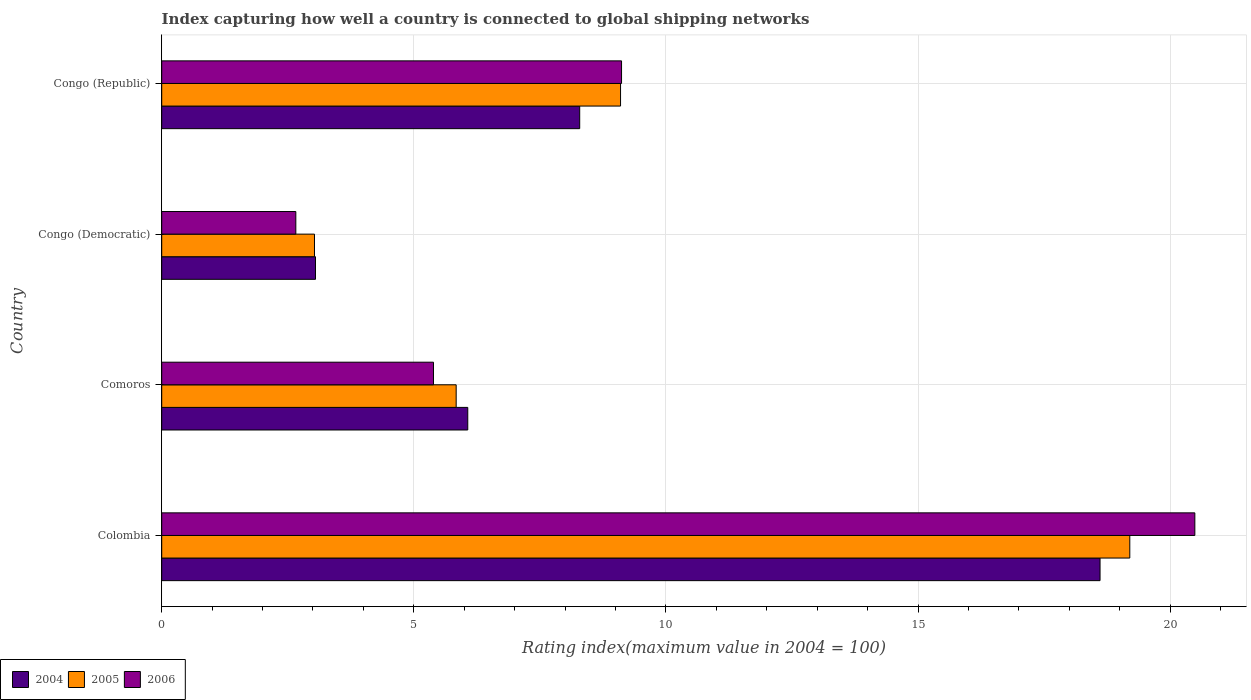How many different coloured bars are there?
Your answer should be very brief. 3. How many groups of bars are there?
Ensure brevity in your answer.  4. Are the number of bars on each tick of the Y-axis equal?
Your answer should be very brief. Yes. How many bars are there on the 2nd tick from the top?
Provide a succinct answer. 3. What is the label of the 3rd group of bars from the top?
Your answer should be compact. Comoros. What is the rating index in 2005 in Congo (Democratic)?
Make the answer very short. 3.03. Across all countries, what is the maximum rating index in 2006?
Your answer should be compact. 20.49. Across all countries, what is the minimum rating index in 2004?
Offer a very short reply. 3.05. In which country was the rating index in 2006 maximum?
Make the answer very short. Colombia. In which country was the rating index in 2006 minimum?
Offer a very short reply. Congo (Democratic). What is the total rating index in 2004 in the graph?
Ensure brevity in your answer.  36.02. What is the difference between the rating index in 2005 in Colombia and that in Comoros?
Ensure brevity in your answer.  13.36. What is the difference between the rating index in 2005 in Congo (Republic) and the rating index in 2004 in Congo (Democratic)?
Provide a succinct answer. 6.05. What is the average rating index in 2006 per country?
Your answer should be very brief. 9.41. What is the difference between the rating index in 2005 and rating index in 2004 in Congo (Democratic)?
Offer a very short reply. -0.02. In how many countries, is the rating index in 2005 greater than 9 ?
Give a very brief answer. 2. What is the ratio of the rating index in 2004 in Colombia to that in Comoros?
Your answer should be very brief. 3.07. Is the rating index in 2004 in Congo (Democratic) less than that in Congo (Republic)?
Your response must be concise. Yes. Is the difference between the rating index in 2005 in Colombia and Congo (Democratic) greater than the difference between the rating index in 2004 in Colombia and Congo (Democratic)?
Offer a very short reply. Yes. What is the difference between the highest and the second highest rating index in 2004?
Your response must be concise. 10.32. What is the difference between the highest and the lowest rating index in 2005?
Keep it short and to the point. 16.17. In how many countries, is the rating index in 2006 greater than the average rating index in 2006 taken over all countries?
Your answer should be very brief. 1. Is the sum of the rating index in 2004 in Congo (Democratic) and Congo (Republic) greater than the maximum rating index in 2006 across all countries?
Provide a short and direct response. No. What does the 1st bar from the bottom in Comoros represents?
Provide a short and direct response. 2004. Is it the case that in every country, the sum of the rating index in 2005 and rating index in 2006 is greater than the rating index in 2004?
Your response must be concise. Yes. How many countries are there in the graph?
Offer a terse response. 4. What is the difference between two consecutive major ticks on the X-axis?
Your response must be concise. 5. Does the graph contain any zero values?
Ensure brevity in your answer.  No. How many legend labels are there?
Ensure brevity in your answer.  3. How are the legend labels stacked?
Give a very brief answer. Horizontal. What is the title of the graph?
Your answer should be compact. Index capturing how well a country is connected to global shipping networks. Does "1985" appear as one of the legend labels in the graph?
Keep it short and to the point. No. What is the label or title of the X-axis?
Provide a short and direct response. Rating index(maximum value in 2004 = 100). What is the label or title of the Y-axis?
Your answer should be compact. Country. What is the Rating index(maximum value in 2004 = 100) in 2004 in Colombia?
Provide a succinct answer. 18.61. What is the Rating index(maximum value in 2004 = 100) in 2006 in Colombia?
Ensure brevity in your answer.  20.49. What is the Rating index(maximum value in 2004 = 100) of 2004 in Comoros?
Your answer should be compact. 6.07. What is the Rating index(maximum value in 2004 = 100) of 2005 in Comoros?
Your answer should be compact. 5.84. What is the Rating index(maximum value in 2004 = 100) in 2006 in Comoros?
Your answer should be compact. 5.39. What is the Rating index(maximum value in 2004 = 100) of 2004 in Congo (Democratic)?
Keep it short and to the point. 3.05. What is the Rating index(maximum value in 2004 = 100) of 2005 in Congo (Democratic)?
Keep it short and to the point. 3.03. What is the Rating index(maximum value in 2004 = 100) of 2006 in Congo (Democratic)?
Your answer should be very brief. 2.66. What is the Rating index(maximum value in 2004 = 100) in 2004 in Congo (Republic)?
Provide a short and direct response. 8.29. What is the Rating index(maximum value in 2004 = 100) in 2006 in Congo (Republic)?
Provide a succinct answer. 9.12. Across all countries, what is the maximum Rating index(maximum value in 2004 = 100) in 2004?
Offer a terse response. 18.61. Across all countries, what is the maximum Rating index(maximum value in 2004 = 100) in 2006?
Offer a very short reply. 20.49. Across all countries, what is the minimum Rating index(maximum value in 2004 = 100) in 2004?
Provide a succinct answer. 3.05. Across all countries, what is the minimum Rating index(maximum value in 2004 = 100) in 2005?
Offer a very short reply. 3.03. Across all countries, what is the minimum Rating index(maximum value in 2004 = 100) in 2006?
Offer a terse response. 2.66. What is the total Rating index(maximum value in 2004 = 100) of 2004 in the graph?
Give a very brief answer. 36.02. What is the total Rating index(maximum value in 2004 = 100) of 2005 in the graph?
Offer a terse response. 37.17. What is the total Rating index(maximum value in 2004 = 100) in 2006 in the graph?
Make the answer very short. 37.66. What is the difference between the Rating index(maximum value in 2004 = 100) of 2004 in Colombia and that in Comoros?
Give a very brief answer. 12.54. What is the difference between the Rating index(maximum value in 2004 = 100) of 2005 in Colombia and that in Comoros?
Keep it short and to the point. 13.36. What is the difference between the Rating index(maximum value in 2004 = 100) of 2006 in Colombia and that in Comoros?
Offer a very short reply. 15.1. What is the difference between the Rating index(maximum value in 2004 = 100) in 2004 in Colombia and that in Congo (Democratic)?
Make the answer very short. 15.56. What is the difference between the Rating index(maximum value in 2004 = 100) in 2005 in Colombia and that in Congo (Democratic)?
Give a very brief answer. 16.17. What is the difference between the Rating index(maximum value in 2004 = 100) in 2006 in Colombia and that in Congo (Democratic)?
Give a very brief answer. 17.83. What is the difference between the Rating index(maximum value in 2004 = 100) of 2004 in Colombia and that in Congo (Republic)?
Offer a terse response. 10.32. What is the difference between the Rating index(maximum value in 2004 = 100) in 2005 in Colombia and that in Congo (Republic)?
Provide a short and direct response. 10.1. What is the difference between the Rating index(maximum value in 2004 = 100) of 2006 in Colombia and that in Congo (Republic)?
Make the answer very short. 11.37. What is the difference between the Rating index(maximum value in 2004 = 100) of 2004 in Comoros and that in Congo (Democratic)?
Offer a terse response. 3.02. What is the difference between the Rating index(maximum value in 2004 = 100) of 2005 in Comoros and that in Congo (Democratic)?
Make the answer very short. 2.81. What is the difference between the Rating index(maximum value in 2004 = 100) in 2006 in Comoros and that in Congo (Democratic)?
Give a very brief answer. 2.73. What is the difference between the Rating index(maximum value in 2004 = 100) of 2004 in Comoros and that in Congo (Republic)?
Provide a succinct answer. -2.22. What is the difference between the Rating index(maximum value in 2004 = 100) in 2005 in Comoros and that in Congo (Republic)?
Your response must be concise. -3.26. What is the difference between the Rating index(maximum value in 2004 = 100) of 2006 in Comoros and that in Congo (Republic)?
Your answer should be very brief. -3.73. What is the difference between the Rating index(maximum value in 2004 = 100) in 2004 in Congo (Democratic) and that in Congo (Republic)?
Offer a terse response. -5.24. What is the difference between the Rating index(maximum value in 2004 = 100) in 2005 in Congo (Democratic) and that in Congo (Republic)?
Ensure brevity in your answer.  -6.07. What is the difference between the Rating index(maximum value in 2004 = 100) in 2006 in Congo (Democratic) and that in Congo (Republic)?
Keep it short and to the point. -6.46. What is the difference between the Rating index(maximum value in 2004 = 100) in 2004 in Colombia and the Rating index(maximum value in 2004 = 100) in 2005 in Comoros?
Keep it short and to the point. 12.77. What is the difference between the Rating index(maximum value in 2004 = 100) of 2004 in Colombia and the Rating index(maximum value in 2004 = 100) of 2006 in Comoros?
Your response must be concise. 13.22. What is the difference between the Rating index(maximum value in 2004 = 100) in 2005 in Colombia and the Rating index(maximum value in 2004 = 100) in 2006 in Comoros?
Provide a short and direct response. 13.81. What is the difference between the Rating index(maximum value in 2004 = 100) of 2004 in Colombia and the Rating index(maximum value in 2004 = 100) of 2005 in Congo (Democratic)?
Offer a very short reply. 15.58. What is the difference between the Rating index(maximum value in 2004 = 100) in 2004 in Colombia and the Rating index(maximum value in 2004 = 100) in 2006 in Congo (Democratic)?
Provide a succinct answer. 15.95. What is the difference between the Rating index(maximum value in 2004 = 100) in 2005 in Colombia and the Rating index(maximum value in 2004 = 100) in 2006 in Congo (Democratic)?
Provide a succinct answer. 16.54. What is the difference between the Rating index(maximum value in 2004 = 100) of 2004 in Colombia and the Rating index(maximum value in 2004 = 100) of 2005 in Congo (Republic)?
Your response must be concise. 9.51. What is the difference between the Rating index(maximum value in 2004 = 100) of 2004 in Colombia and the Rating index(maximum value in 2004 = 100) of 2006 in Congo (Republic)?
Provide a succinct answer. 9.49. What is the difference between the Rating index(maximum value in 2004 = 100) in 2005 in Colombia and the Rating index(maximum value in 2004 = 100) in 2006 in Congo (Republic)?
Ensure brevity in your answer.  10.08. What is the difference between the Rating index(maximum value in 2004 = 100) of 2004 in Comoros and the Rating index(maximum value in 2004 = 100) of 2005 in Congo (Democratic)?
Provide a succinct answer. 3.04. What is the difference between the Rating index(maximum value in 2004 = 100) in 2004 in Comoros and the Rating index(maximum value in 2004 = 100) in 2006 in Congo (Democratic)?
Offer a very short reply. 3.41. What is the difference between the Rating index(maximum value in 2004 = 100) of 2005 in Comoros and the Rating index(maximum value in 2004 = 100) of 2006 in Congo (Democratic)?
Your answer should be compact. 3.18. What is the difference between the Rating index(maximum value in 2004 = 100) of 2004 in Comoros and the Rating index(maximum value in 2004 = 100) of 2005 in Congo (Republic)?
Provide a short and direct response. -3.03. What is the difference between the Rating index(maximum value in 2004 = 100) of 2004 in Comoros and the Rating index(maximum value in 2004 = 100) of 2006 in Congo (Republic)?
Give a very brief answer. -3.05. What is the difference between the Rating index(maximum value in 2004 = 100) of 2005 in Comoros and the Rating index(maximum value in 2004 = 100) of 2006 in Congo (Republic)?
Ensure brevity in your answer.  -3.28. What is the difference between the Rating index(maximum value in 2004 = 100) in 2004 in Congo (Democratic) and the Rating index(maximum value in 2004 = 100) in 2005 in Congo (Republic)?
Keep it short and to the point. -6.05. What is the difference between the Rating index(maximum value in 2004 = 100) of 2004 in Congo (Democratic) and the Rating index(maximum value in 2004 = 100) of 2006 in Congo (Republic)?
Your answer should be very brief. -6.07. What is the difference between the Rating index(maximum value in 2004 = 100) in 2005 in Congo (Democratic) and the Rating index(maximum value in 2004 = 100) in 2006 in Congo (Republic)?
Offer a very short reply. -6.09. What is the average Rating index(maximum value in 2004 = 100) of 2004 per country?
Give a very brief answer. 9.01. What is the average Rating index(maximum value in 2004 = 100) of 2005 per country?
Provide a short and direct response. 9.29. What is the average Rating index(maximum value in 2004 = 100) in 2006 per country?
Give a very brief answer. 9.41. What is the difference between the Rating index(maximum value in 2004 = 100) of 2004 and Rating index(maximum value in 2004 = 100) of 2005 in Colombia?
Make the answer very short. -0.59. What is the difference between the Rating index(maximum value in 2004 = 100) in 2004 and Rating index(maximum value in 2004 = 100) in 2006 in Colombia?
Your response must be concise. -1.88. What is the difference between the Rating index(maximum value in 2004 = 100) of 2005 and Rating index(maximum value in 2004 = 100) of 2006 in Colombia?
Make the answer very short. -1.29. What is the difference between the Rating index(maximum value in 2004 = 100) of 2004 and Rating index(maximum value in 2004 = 100) of 2005 in Comoros?
Make the answer very short. 0.23. What is the difference between the Rating index(maximum value in 2004 = 100) of 2004 and Rating index(maximum value in 2004 = 100) of 2006 in Comoros?
Give a very brief answer. 0.68. What is the difference between the Rating index(maximum value in 2004 = 100) in 2005 and Rating index(maximum value in 2004 = 100) in 2006 in Comoros?
Ensure brevity in your answer.  0.45. What is the difference between the Rating index(maximum value in 2004 = 100) of 2004 and Rating index(maximum value in 2004 = 100) of 2005 in Congo (Democratic)?
Provide a short and direct response. 0.02. What is the difference between the Rating index(maximum value in 2004 = 100) of 2004 and Rating index(maximum value in 2004 = 100) of 2006 in Congo (Democratic)?
Give a very brief answer. 0.39. What is the difference between the Rating index(maximum value in 2004 = 100) of 2005 and Rating index(maximum value in 2004 = 100) of 2006 in Congo (Democratic)?
Offer a terse response. 0.37. What is the difference between the Rating index(maximum value in 2004 = 100) in 2004 and Rating index(maximum value in 2004 = 100) in 2005 in Congo (Republic)?
Offer a very short reply. -0.81. What is the difference between the Rating index(maximum value in 2004 = 100) of 2004 and Rating index(maximum value in 2004 = 100) of 2006 in Congo (Republic)?
Ensure brevity in your answer.  -0.83. What is the difference between the Rating index(maximum value in 2004 = 100) in 2005 and Rating index(maximum value in 2004 = 100) in 2006 in Congo (Republic)?
Offer a terse response. -0.02. What is the ratio of the Rating index(maximum value in 2004 = 100) of 2004 in Colombia to that in Comoros?
Make the answer very short. 3.07. What is the ratio of the Rating index(maximum value in 2004 = 100) in 2005 in Colombia to that in Comoros?
Your answer should be very brief. 3.29. What is the ratio of the Rating index(maximum value in 2004 = 100) of 2006 in Colombia to that in Comoros?
Give a very brief answer. 3.8. What is the ratio of the Rating index(maximum value in 2004 = 100) of 2004 in Colombia to that in Congo (Democratic)?
Provide a short and direct response. 6.1. What is the ratio of the Rating index(maximum value in 2004 = 100) of 2005 in Colombia to that in Congo (Democratic)?
Your response must be concise. 6.34. What is the ratio of the Rating index(maximum value in 2004 = 100) in 2006 in Colombia to that in Congo (Democratic)?
Provide a succinct answer. 7.7. What is the ratio of the Rating index(maximum value in 2004 = 100) of 2004 in Colombia to that in Congo (Republic)?
Offer a very short reply. 2.24. What is the ratio of the Rating index(maximum value in 2004 = 100) of 2005 in Colombia to that in Congo (Republic)?
Your answer should be very brief. 2.11. What is the ratio of the Rating index(maximum value in 2004 = 100) of 2006 in Colombia to that in Congo (Republic)?
Keep it short and to the point. 2.25. What is the ratio of the Rating index(maximum value in 2004 = 100) of 2004 in Comoros to that in Congo (Democratic)?
Provide a succinct answer. 1.99. What is the ratio of the Rating index(maximum value in 2004 = 100) of 2005 in Comoros to that in Congo (Democratic)?
Your answer should be very brief. 1.93. What is the ratio of the Rating index(maximum value in 2004 = 100) of 2006 in Comoros to that in Congo (Democratic)?
Give a very brief answer. 2.03. What is the ratio of the Rating index(maximum value in 2004 = 100) of 2004 in Comoros to that in Congo (Republic)?
Give a very brief answer. 0.73. What is the ratio of the Rating index(maximum value in 2004 = 100) in 2005 in Comoros to that in Congo (Republic)?
Your answer should be compact. 0.64. What is the ratio of the Rating index(maximum value in 2004 = 100) of 2006 in Comoros to that in Congo (Republic)?
Keep it short and to the point. 0.59. What is the ratio of the Rating index(maximum value in 2004 = 100) in 2004 in Congo (Democratic) to that in Congo (Republic)?
Your answer should be very brief. 0.37. What is the ratio of the Rating index(maximum value in 2004 = 100) in 2005 in Congo (Democratic) to that in Congo (Republic)?
Offer a terse response. 0.33. What is the ratio of the Rating index(maximum value in 2004 = 100) in 2006 in Congo (Democratic) to that in Congo (Republic)?
Make the answer very short. 0.29. What is the difference between the highest and the second highest Rating index(maximum value in 2004 = 100) in 2004?
Your response must be concise. 10.32. What is the difference between the highest and the second highest Rating index(maximum value in 2004 = 100) in 2005?
Provide a short and direct response. 10.1. What is the difference between the highest and the second highest Rating index(maximum value in 2004 = 100) in 2006?
Keep it short and to the point. 11.37. What is the difference between the highest and the lowest Rating index(maximum value in 2004 = 100) of 2004?
Offer a terse response. 15.56. What is the difference between the highest and the lowest Rating index(maximum value in 2004 = 100) in 2005?
Provide a succinct answer. 16.17. What is the difference between the highest and the lowest Rating index(maximum value in 2004 = 100) in 2006?
Give a very brief answer. 17.83. 